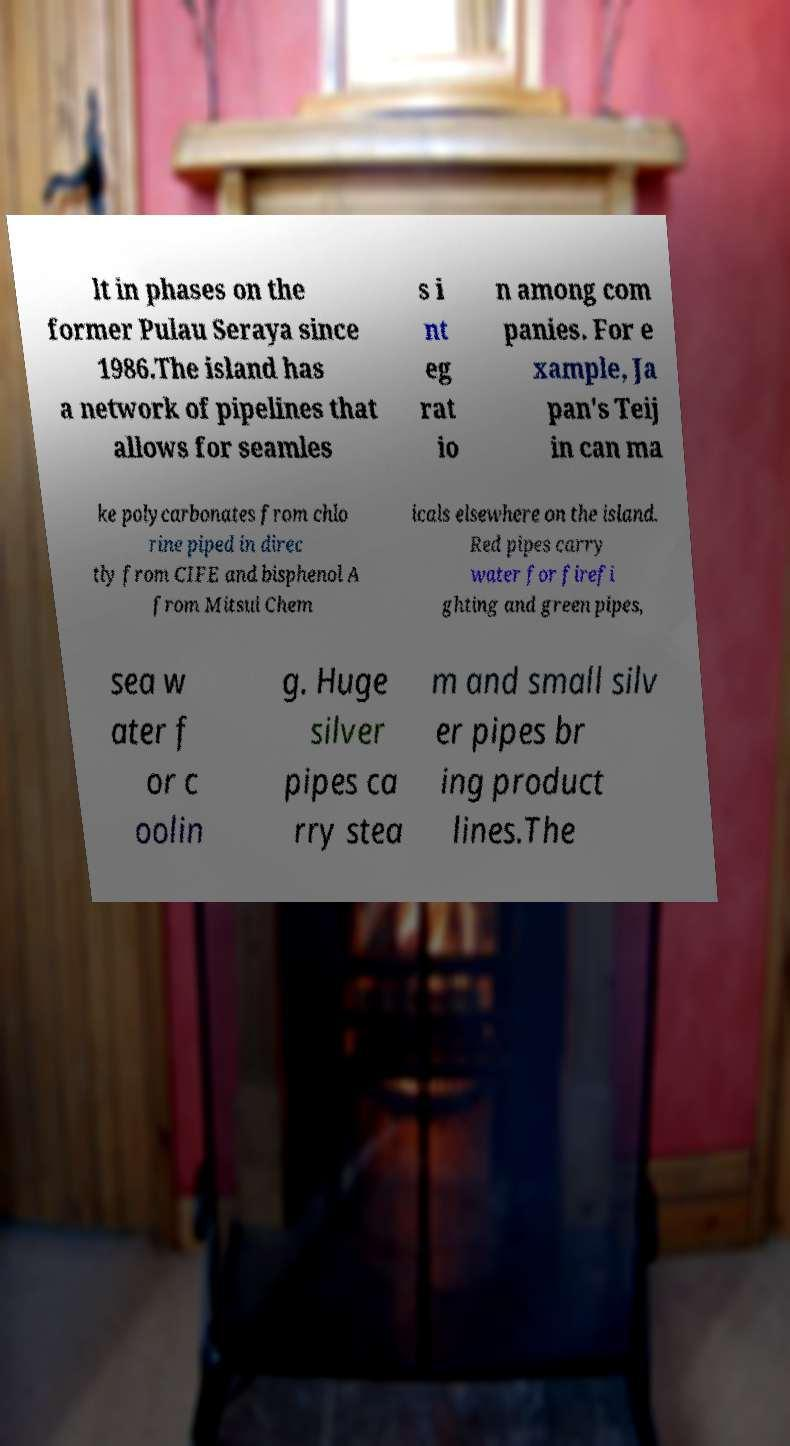What messages or text are displayed in this image? I need them in a readable, typed format. lt in phases on the former Pulau Seraya since 1986.The island has a network of pipelines that allows for seamles s i nt eg rat io n among com panies. For e xample, Ja pan's Teij in can ma ke polycarbonates from chlo rine piped in direc tly from CIFE and bisphenol A from Mitsui Chem icals elsewhere on the island. Red pipes carry water for firefi ghting and green pipes, sea w ater f or c oolin g. Huge silver pipes ca rry stea m and small silv er pipes br ing product lines.The 